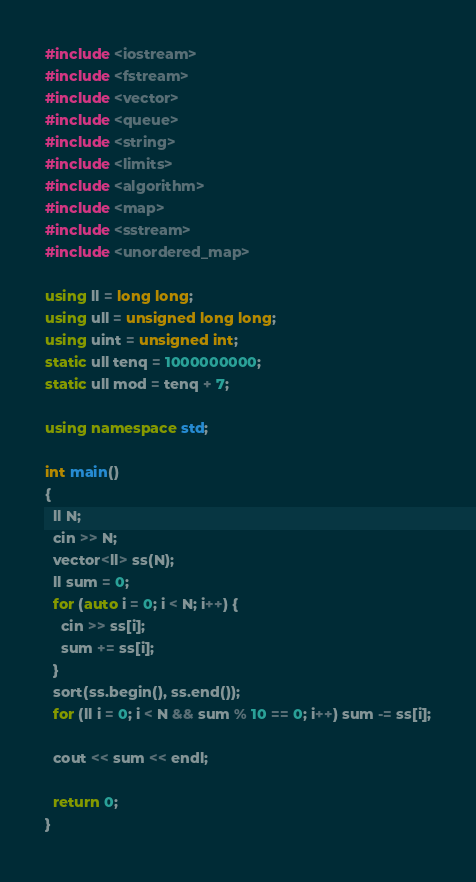<code> <loc_0><loc_0><loc_500><loc_500><_C++_>#include <iostream>
#include <fstream>
#include <vector>
#include <queue>
#include <string>
#include <limits>
#include <algorithm>
#include <map>
#include <sstream>
#include <unordered_map>

using ll = long long;
using ull = unsigned long long;
using uint = unsigned int;
static ull tenq = 1000000000;
static ull mod = tenq + 7;

using namespace std;

int main()
{
  ll N;
  cin >> N;
  vector<ll> ss(N);
  ll sum = 0;
  for (auto i = 0; i < N; i++) {
    cin >> ss[i];
    sum += ss[i];
  }
  sort(ss.begin(), ss.end());
  for (ll i = 0; i < N && sum % 10 == 0; i++) sum -= ss[i];

  cout << sum << endl;

  return 0;
}
</code> 